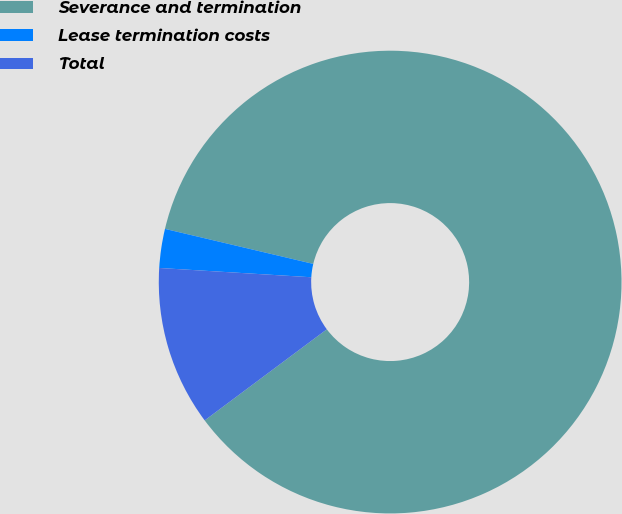Convert chart. <chart><loc_0><loc_0><loc_500><loc_500><pie_chart><fcel>Severance and termination<fcel>Lease termination costs<fcel>Total<nl><fcel>86.1%<fcel>2.72%<fcel>11.17%<nl></chart> 